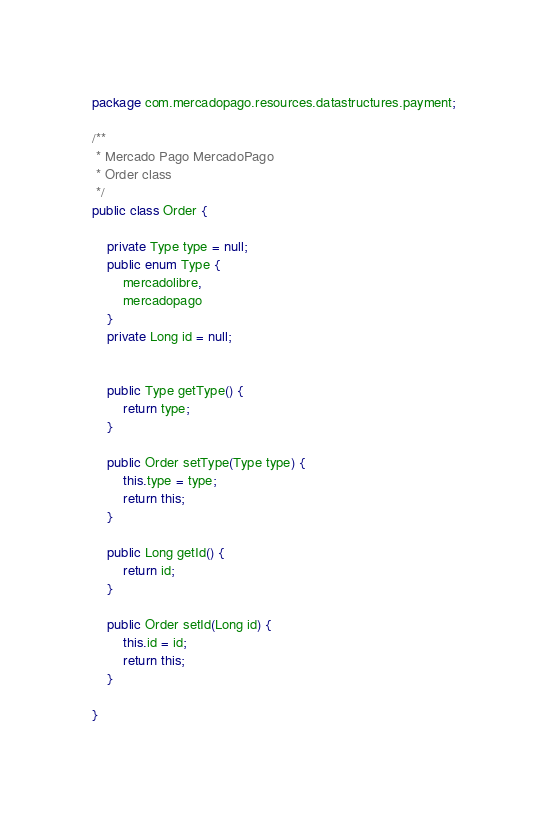Convert code to text. <code><loc_0><loc_0><loc_500><loc_500><_Java_>package com.mercadopago.resources.datastructures.payment;

/**
 * Mercado Pago MercadoPago
 * Order class
 */
public class Order {

    private Type type = null;
    public enum Type {
        mercadolibre,
        mercadopago
    }
    private Long id = null;


    public Type getType() {
        return type;
    }

    public Order setType(Type type) {
        this.type = type;
        return this;
    }

    public Long getId() {
        return id;
    }

    public Order setId(Long id) {
        this.id = id;
        return this;
    }

}
</code> 